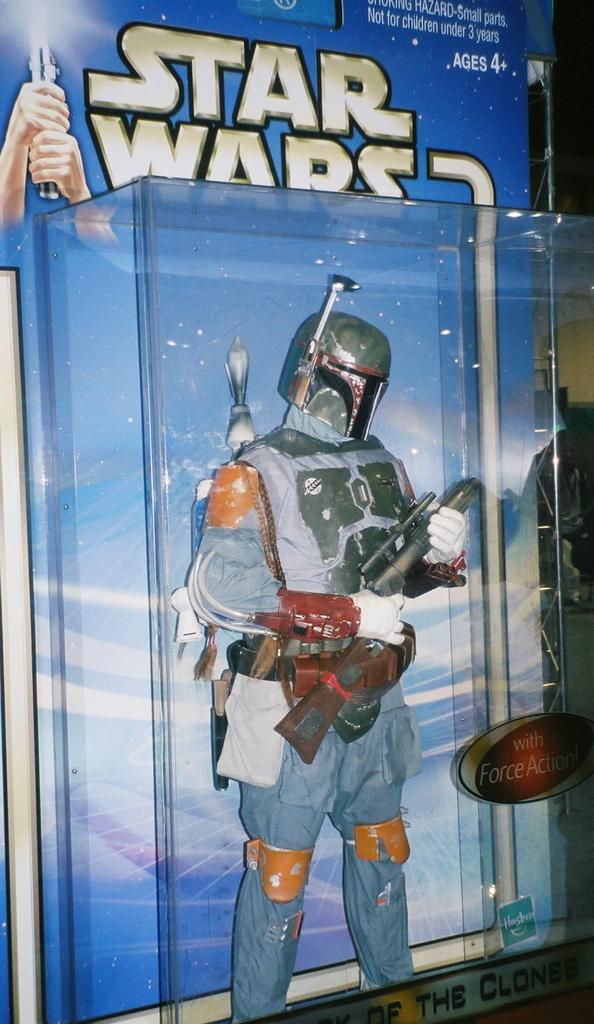<image>
Render a clear and concise summary of the photo. A Star Wars action figure package states it is for ages 4+. 